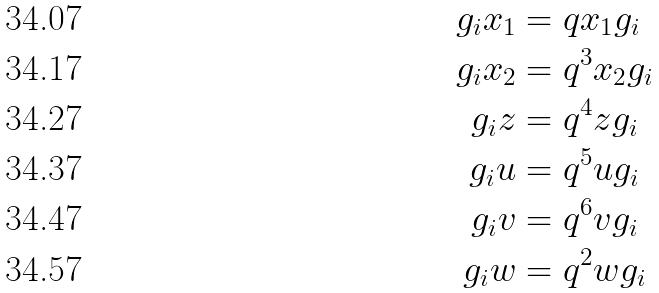<formula> <loc_0><loc_0><loc_500><loc_500>g _ { i } x _ { 1 } & = q x _ { 1 } g _ { i } \\ g _ { i } x _ { 2 } & = q ^ { 3 } x _ { 2 } g _ { i } \\ g _ { i } z & = q ^ { 4 } z g _ { i } \\ g _ { i } u & = q ^ { 5 } u g _ { i } \\ g _ { i } v & = q ^ { 6 } v g _ { i } \\ g _ { i } w & = q ^ { 2 } w g _ { i }</formula> 